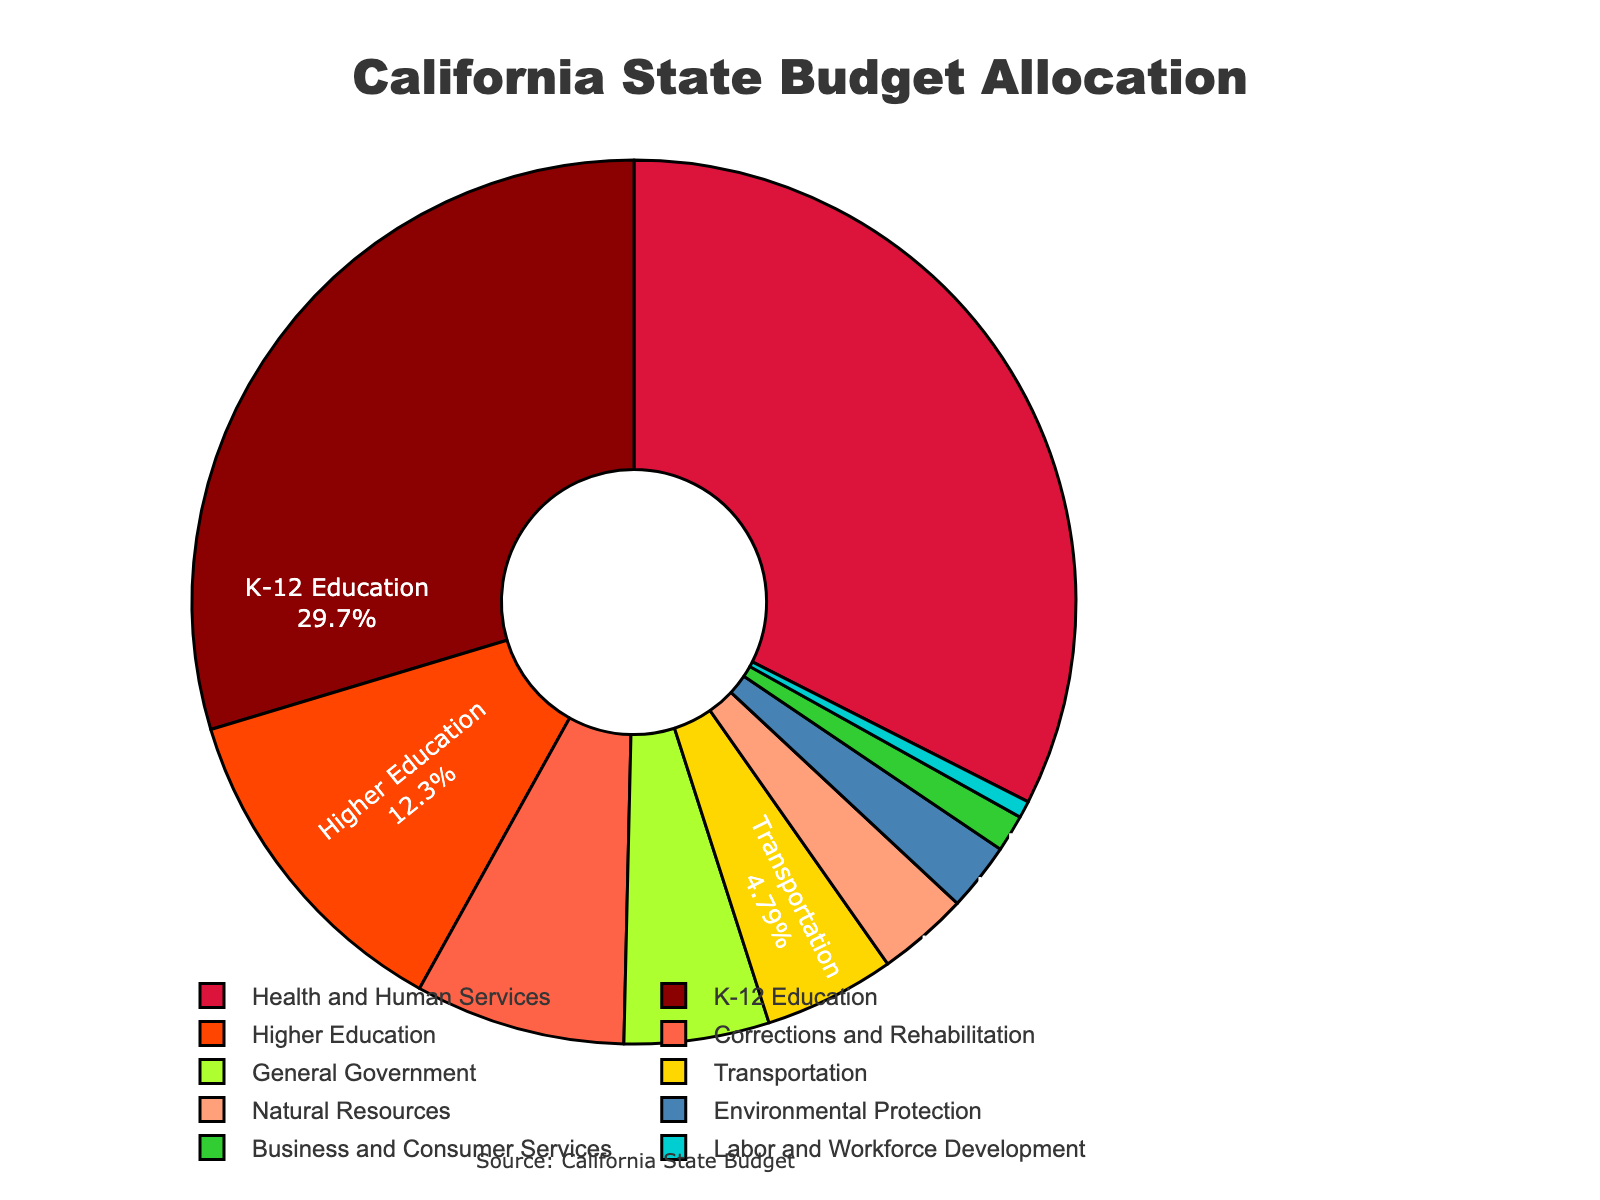Which category has the highest percentage allocation in the California state budget? By looking at the pie chart, we can see that Health and Human Services has the largest slice. The percentage indicated for this category is 31.2%.
Answer: Health and Human Services Which two categories together make up more than 50% of the total budget? Adding the percentages of K-12 Education (28.5%) and Health and Human Services (31.2%) results in 28.5% + 31.2% = 59.7%, which is more than 50%.
Answer: K-12 Education and Health and Human Services How much more is allocated to K-12 Education compared to Higher Education? K-12 Education has an allocation of 28.5%, while Higher Education has 11.8%. The difference is 28.5% - 11.8% = 16.7%.
Answer: 16.7% What is the combined percentage allocation for Environmental Protection and Natural Resources? Environmental Protection is 2.4% and Natural Resources is 3.2%. The sum of these two categories is 2.4% + 3.2% = 5.6%.
Answer: 5.6% Which category has the smallest allocation? By observing the size of the slices in the pie chart, we see that Labor and Workforce Development has the smallest slice, which is 0.6%.
Answer: Labor and Workforce Development Are there more funds allocated to Transportation or Corrections and Rehabilitation? Comparing the two percentages, Transportation has 4.6% and Corrections and Rehabilitation has 7.4%. Therefore, more funds are allocated to Corrections and Rehabilitation.
Answer: Corrections and Rehabilitation By what factor is the budget for Health and Human Services greater than Labor and Workforce Development? Health and Human Services is allocated 31.2%, and Labor and Workforce Development is allocated 0.6%. The factor is calculated as 31.2% / 0.6% = 52.
Answer: 52 Which categories have an allocation between 1% to 5%? Observing the pie chart, we find that Business and Consumer Services (1.3%), Environmental Protection (2.4%), Natural Resources (3.2%), and Transportation (4.6%) all fall within the 1% to 5% range.
Answer: Business and Consumer Services, Environmental Protection, Natural Resources, Transportation What percentage of the budget is dedicated to general administration and government functions? The category "General Government" represents this function, which has an allocation of 5.1%.
Answer: 5.1% 